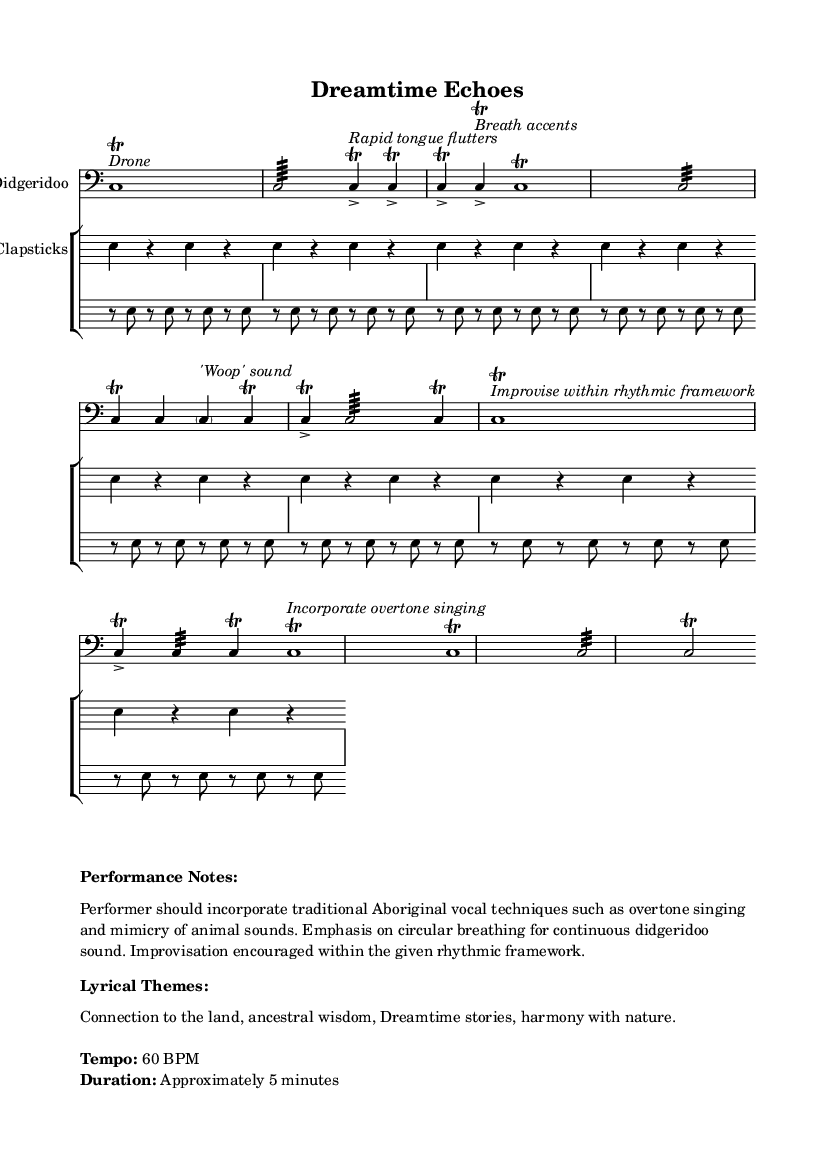What is the time signature of this music? The time signature is shown at the beginning of the music as 4/4, indicating that there are four beats in each measure.
Answer: 4/4 What is the tempo marking for this piece? The tempo marking is indicated in the performance notes, which states the piece should be played at 60 BPM (beats per minute).
Answer: 60 BPM What instrument is primarily featured in this sheet music? The primary instrument is labeled at the top of the staff, which indicates that the music is for the Didgeridoo.
Answer: Didgeridoo What vocal techniques are encouraged in the performance notes? The performance notes suggest incorporating traditional Aboriginal vocal techniques such as overtone singing and mimicry of animal sounds.
Answer: Overtone singing How long is the approximate duration of the performance? The duration is mentioned in the performance notes, indicating that the piece lasts approximately 5 minutes.
Answer: Approximately 5 minutes What unique rhythmic feature is emphasized for the Didgeridoo player? The performance notes highlight the importance of circular breathing to allow for a continuous sound on the Didgeridoo, crucial for its traditional use.
Answer: Circular breathing What is the main theme of the lyrical content indicated? The lyrical themes are detailed in the performance notes, focusing on connection to the land and ancestral wisdom, often expressed through traditional stories.
Answer: Connection to the land, ancestral wisdom 